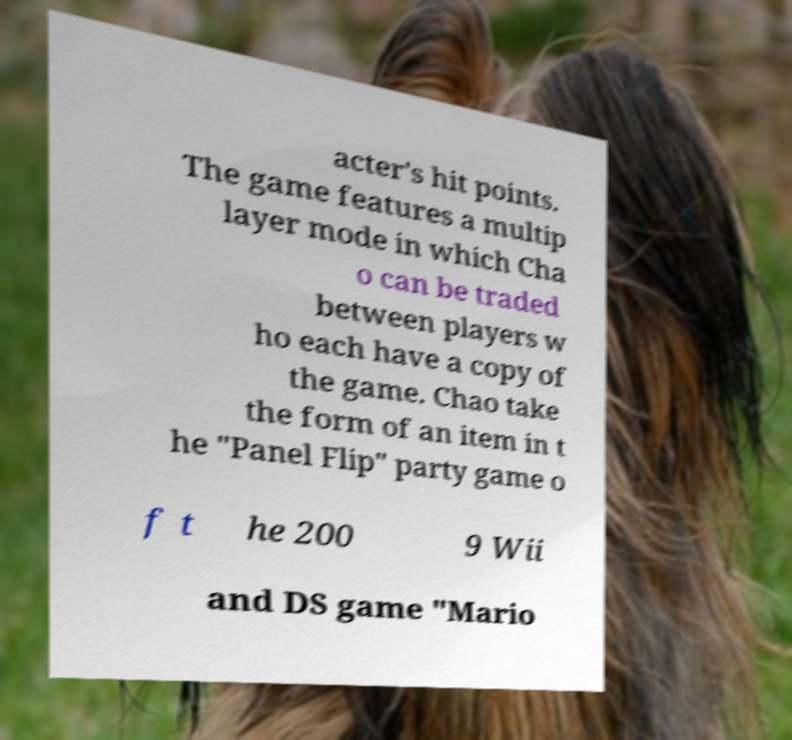There's text embedded in this image that I need extracted. Can you transcribe it verbatim? acter's hit points. The game features a multip layer mode in which Cha o can be traded between players w ho each have a copy of the game. Chao take the form of an item in t he "Panel Flip" party game o f t he 200 9 Wii and DS game "Mario 